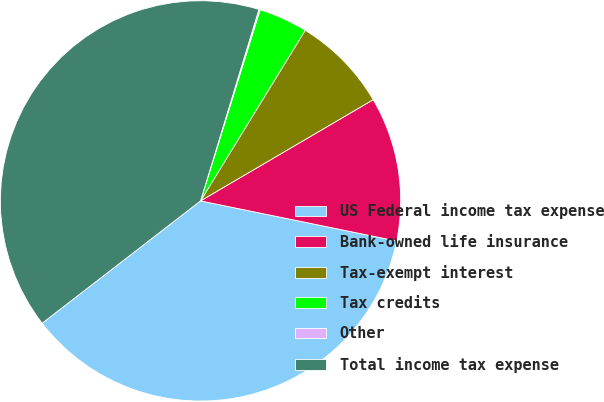Convert chart. <chart><loc_0><loc_0><loc_500><loc_500><pie_chart><fcel>US Federal income tax expense<fcel>Bank-owned life insurance<fcel>Tax-exempt interest<fcel>Tax credits<fcel>Other<fcel>Total income tax expense<nl><fcel>36.32%<fcel>11.65%<fcel>7.8%<fcel>3.95%<fcel>0.1%<fcel>40.17%<nl></chart> 